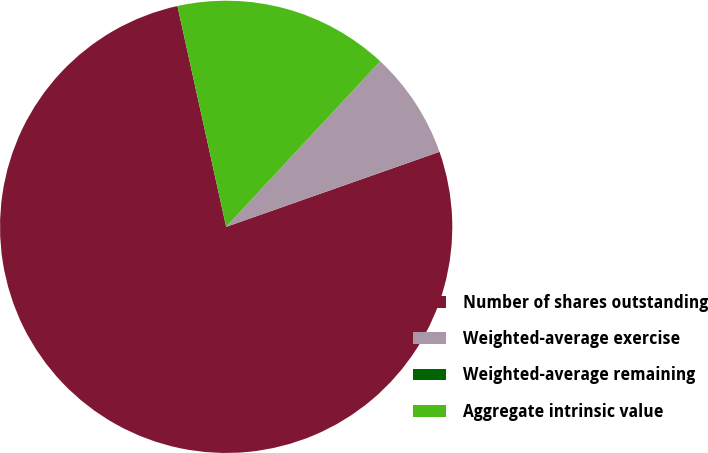Convert chart to OTSL. <chart><loc_0><loc_0><loc_500><loc_500><pie_chart><fcel>Number of shares outstanding<fcel>Weighted-average exercise<fcel>Weighted-average remaining<fcel>Aggregate intrinsic value<nl><fcel>76.92%<fcel>7.69%<fcel>0.0%<fcel>15.38%<nl></chart> 